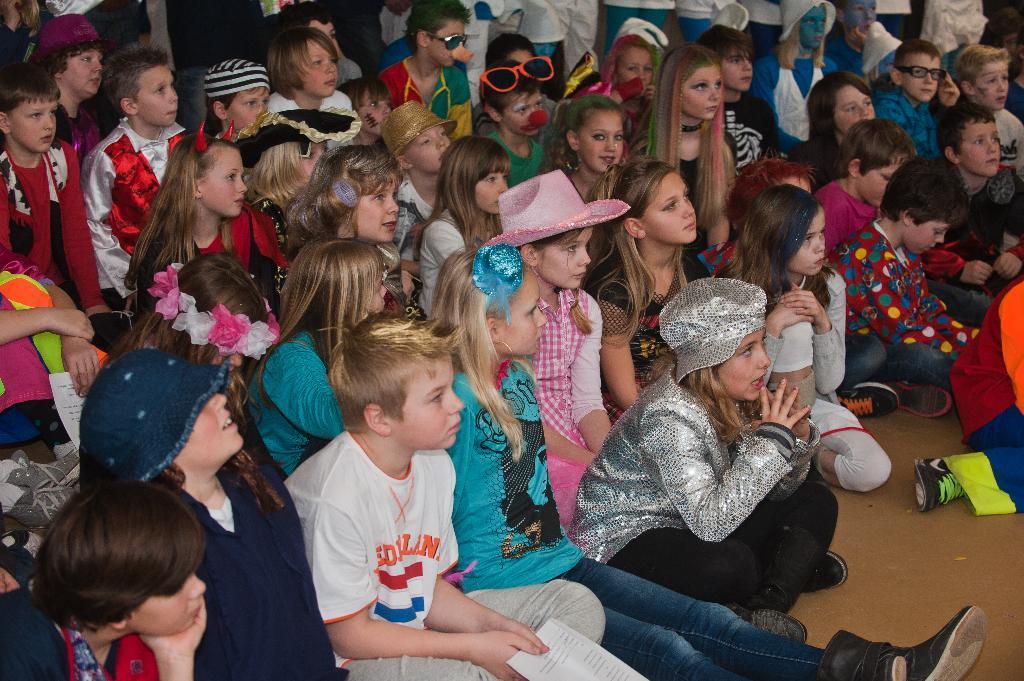Could you give a brief overview of what you see in this image? In this image there are persons sitting and standing. 